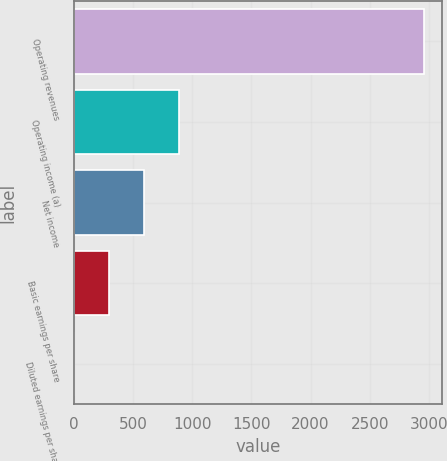Convert chart to OTSL. <chart><loc_0><loc_0><loc_500><loc_500><bar_chart><fcel>Operating revenues<fcel>Operating income (a)<fcel>Net income<fcel>Basic earnings per share<fcel>Diluted earnings per share<nl><fcel>2961<fcel>889.44<fcel>593.5<fcel>297.56<fcel>1.62<nl></chart> 